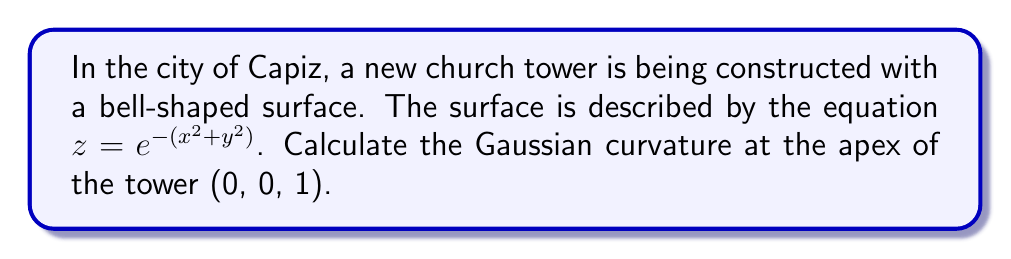Teach me how to tackle this problem. To find the Gaussian curvature of the bell-shaped surface, we'll follow these steps:

1) The Gaussian curvature K is given by $K = \frac{LN - M^2}{EG - F^2}$, where L, M, N are coefficients of the second fundamental form, and E, F, G are coefficients of the first fundamental form.

2) First, let's calculate the partial derivatives:
   $z_x = -2xe^{-(x^2+y^2)}$
   $z_y = -2ye^{-(x^2+y^2)}$
   $z_{xx} = (-2+4x^2)e^{-(x^2+y^2)}$
   $z_{yy} = (-2+4y^2)e^{-(x^2+y^2)}$
   $z_{xy} = 4xye^{-(x^2+y^2)}$

3) Now, calculate E, F, G:
   $E = 1 + z_x^2 = 1 + 4x^2e^{-2(x^2+y^2)}$
   $F = z_x z_y = 4xye^{-2(x^2+y^2)}$
   $G = 1 + z_y^2 = 1 + 4y^2e^{-2(x^2+y^2)}$

4) Calculate the unit normal vector:
   $\vec{n} = \frac{(-z_x, -z_y, 1)}{\sqrt{1 + z_x^2 + z_y^2}}$

5) Calculate L, M, N:
   $L = \frac{z_{xx}}{\sqrt{1 + z_x^2 + z_y^2}} = \frac{(-2+4x^2)e^{-(x^2+y^2)}}{\sqrt{1 + 4(x^2+y^2)e^{-2(x^2+y^2)}}}$
   $M = \frac{z_{xy}}{\sqrt{1 + z_x^2 + z_y^2}} = \frac{4xye^{-(x^2+y^2)}}{\sqrt{1 + 4(x^2+y^2)e^{-2(x^2+y^2)}}}$
   $N = \frac{z_{yy}}{\sqrt{1 + z_x^2 + z_y^2}} = \frac{(-2+4y^2)e^{-(x^2+y^2)}}{\sqrt{1 + 4(x^2+y^2)e^{-2(x^2+y^2)}}}$

6) At the apex (0, 0, 1), many terms simplify:
   $E = G = 1$, $F = 0$
   $L = N = -2e^0 = -2$, $M = 0$

7) Now we can calculate the Gaussian curvature at the apex:
   $K = \frac{LN - M^2}{EG - F^2} = \frac{(-2)(-2) - 0^2}{(1)(1) - 0^2} = 4$

Therefore, the Gaussian curvature at the apex of the church tower is 4.
Answer: $K = 4$ 